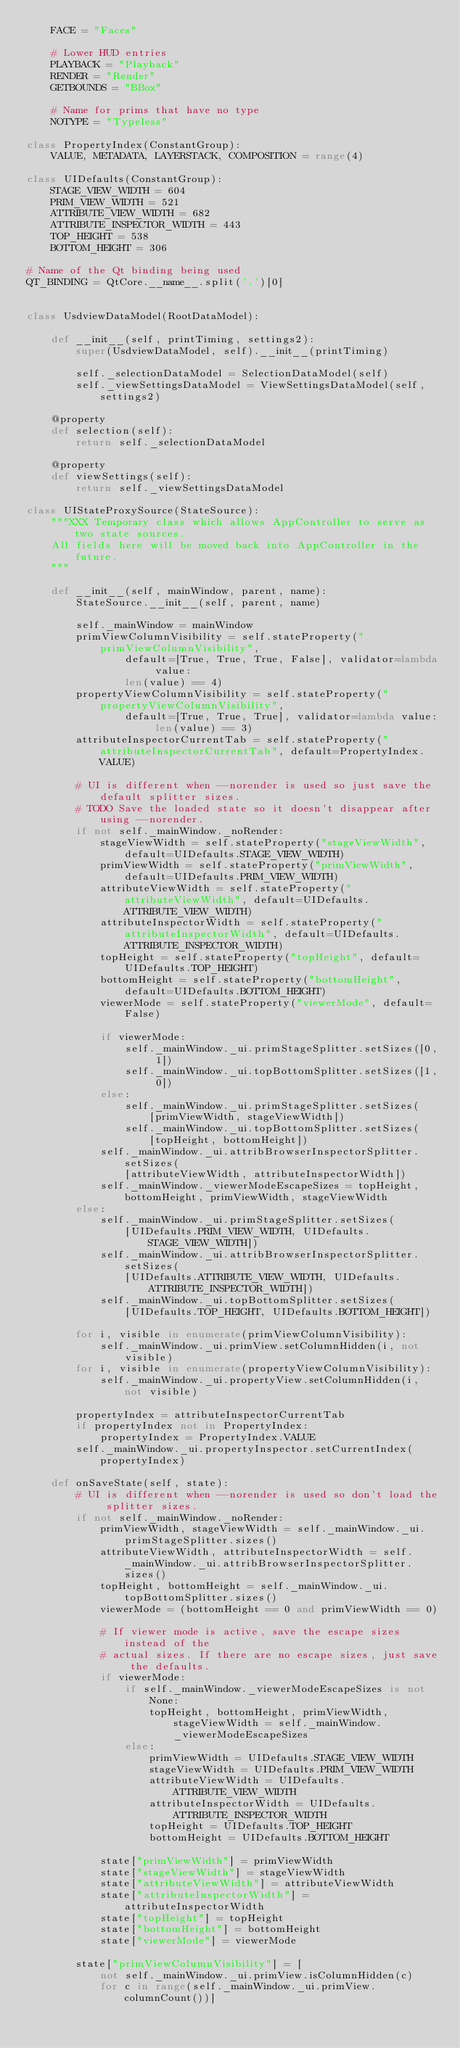Convert code to text. <code><loc_0><loc_0><loc_500><loc_500><_Python_>    FACE = "Faces"

    # Lower HUD entries
    PLAYBACK = "Playback"
    RENDER = "Render"
    GETBOUNDS = "BBox"

    # Name for prims that have no type
    NOTYPE = "Typeless"

class PropertyIndex(ConstantGroup):
    VALUE, METADATA, LAYERSTACK, COMPOSITION = range(4)

class UIDefaults(ConstantGroup):
    STAGE_VIEW_WIDTH = 604
    PRIM_VIEW_WIDTH = 521
    ATTRIBUTE_VIEW_WIDTH = 682
    ATTRIBUTE_INSPECTOR_WIDTH = 443
    TOP_HEIGHT = 538
    BOTTOM_HEIGHT = 306

# Name of the Qt binding being used
QT_BINDING = QtCore.__name__.split('.')[0]


class UsdviewDataModel(RootDataModel):

    def __init__(self, printTiming, settings2):
        super(UsdviewDataModel, self).__init__(printTiming)

        self._selectionDataModel = SelectionDataModel(self)
        self._viewSettingsDataModel = ViewSettingsDataModel(self, settings2)

    @property
    def selection(self):
        return self._selectionDataModel

    @property
    def viewSettings(self):
        return self._viewSettingsDataModel

class UIStateProxySource(StateSource):
    """XXX Temporary class which allows AppController to serve as two state sources.
    All fields here will be moved back into AppController in the future.
    """

    def __init__(self, mainWindow, parent, name):
        StateSource.__init__(self, parent, name)

        self._mainWindow = mainWindow
        primViewColumnVisibility = self.stateProperty("primViewColumnVisibility",
                default=[True, True, True, False], validator=lambda value: 
                len(value) == 4)
        propertyViewColumnVisibility = self.stateProperty("propertyViewColumnVisibility",
                default=[True, True, True], validator=lambda value: len(value) == 3)
        attributeInspectorCurrentTab = self.stateProperty("attributeInspectorCurrentTab", default=PropertyIndex.VALUE)

        # UI is different when --norender is used so just save the default splitter sizes.
        # TODO Save the loaded state so it doesn't disappear after using --norender.
        if not self._mainWindow._noRender:
            stageViewWidth = self.stateProperty("stageViewWidth", default=UIDefaults.STAGE_VIEW_WIDTH)
            primViewWidth = self.stateProperty("primViewWidth", default=UIDefaults.PRIM_VIEW_WIDTH)
            attributeViewWidth = self.stateProperty("attributeViewWidth", default=UIDefaults.ATTRIBUTE_VIEW_WIDTH)
            attributeInspectorWidth = self.stateProperty("attributeInspectorWidth", default=UIDefaults.ATTRIBUTE_INSPECTOR_WIDTH)
            topHeight = self.stateProperty("topHeight", default=UIDefaults.TOP_HEIGHT)
            bottomHeight = self.stateProperty("bottomHeight", default=UIDefaults.BOTTOM_HEIGHT)
            viewerMode = self.stateProperty("viewerMode", default=False)

            if viewerMode:
                self._mainWindow._ui.primStageSplitter.setSizes([0, 1])
                self._mainWindow._ui.topBottomSplitter.setSizes([1, 0])
            else:
                self._mainWindow._ui.primStageSplitter.setSizes(
                    [primViewWidth, stageViewWidth])
                self._mainWindow._ui.topBottomSplitter.setSizes(
                    [topHeight, bottomHeight])
            self._mainWindow._ui.attribBrowserInspectorSplitter.setSizes(
                [attributeViewWidth, attributeInspectorWidth])
            self._mainWindow._viewerModeEscapeSizes = topHeight, bottomHeight, primViewWidth, stageViewWidth
        else:
            self._mainWindow._ui.primStageSplitter.setSizes(
                [UIDefaults.PRIM_VIEW_WIDTH, UIDefaults.STAGE_VIEW_WIDTH])
            self._mainWindow._ui.attribBrowserInspectorSplitter.setSizes(
                [UIDefaults.ATTRIBUTE_VIEW_WIDTH, UIDefaults.ATTRIBUTE_INSPECTOR_WIDTH])
            self._mainWindow._ui.topBottomSplitter.setSizes(
                [UIDefaults.TOP_HEIGHT, UIDefaults.BOTTOM_HEIGHT])

        for i, visible in enumerate(primViewColumnVisibility):
            self._mainWindow._ui.primView.setColumnHidden(i, not visible)
        for i, visible in enumerate(propertyViewColumnVisibility):
            self._mainWindow._ui.propertyView.setColumnHidden(i, not visible)

        propertyIndex = attributeInspectorCurrentTab
        if propertyIndex not in PropertyIndex:
            propertyIndex = PropertyIndex.VALUE
        self._mainWindow._ui.propertyInspector.setCurrentIndex(propertyIndex)

    def onSaveState(self, state):
        # UI is different when --norender is used so don't load the splitter sizes.
        if not self._mainWindow._noRender:
            primViewWidth, stageViewWidth = self._mainWindow._ui.primStageSplitter.sizes()
            attributeViewWidth, attributeInspectorWidth = self._mainWindow._ui.attribBrowserInspectorSplitter.sizes()
            topHeight, bottomHeight = self._mainWindow._ui.topBottomSplitter.sizes()
            viewerMode = (bottomHeight == 0 and primViewWidth == 0)

            # If viewer mode is active, save the escape sizes instead of the
            # actual sizes. If there are no escape sizes, just save the defaults.
            if viewerMode:
                if self._mainWindow._viewerModeEscapeSizes is not None:
                    topHeight, bottomHeight, primViewWidth, stageViewWidth = self._mainWindow._viewerModeEscapeSizes
                else:
                    primViewWidth = UIDefaults.STAGE_VIEW_WIDTH
                    stageViewWidth = UIDefaults.PRIM_VIEW_WIDTH
                    attributeViewWidth = UIDefaults.ATTRIBUTE_VIEW_WIDTH
                    attributeInspectorWidth = UIDefaults.ATTRIBUTE_INSPECTOR_WIDTH
                    topHeight = UIDefaults.TOP_HEIGHT
                    bottomHeight = UIDefaults.BOTTOM_HEIGHT

            state["primViewWidth"] = primViewWidth
            state["stageViewWidth"] = stageViewWidth
            state["attributeViewWidth"] = attributeViewWidth
            state["attributeInspectorWidth"] = attributeInspectorWidth
            state["topHeight"] = topHeight
            state["bottomHeight"] = bottomHeight
            state["viewerMode"] = viewerMode

        state["primViewColumnVisibility"] = [
            not self._mainWindow._ui.primView.isColumnHidden(c)
            for c in range(self._mainWindow._ui.primView.columnCount())]</code> 